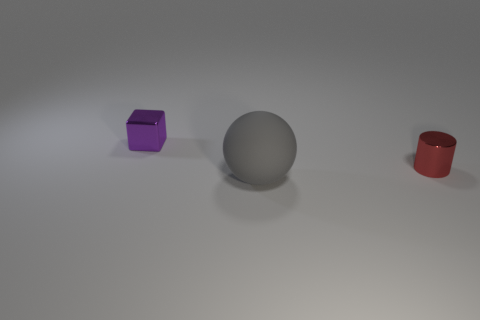The metal cylinder is what size?
Your answer should be very brief. Small. How many things are red shiny cylinders or red rubber objects?
Provide a short and direct response. 1. What color is the small cylinder that is made of the same material as the small purple object?
Keep it short and to the point. Red. Is the shape of the object that is to the right of the big gray rubber ball the same as  the gray matte object?
Your answer should be compact. No. How many things are either metallic things that are to the left of the rubber sphere or red things that are in front of the tiny purple thing?
Ensure brevity in your answer.  2. Are there any other things that are the same shape as the small purple shiny thing?
Your response must be concise. No. There is a gray thing; is its shape the same as the tiny shiny object that is in front of the tiny cube?
Provide a short and direct response. No. What is the red cylinder made of?
Ensure brevity in your answer.  Metal. What number of other things are the same material as the tiny cube?
Provide a short and direct response. 1. Is the tiny cylinder made of the same material as the big gray sphere that is in front of the tiny red metallic cylinder?
Provide a succinct answer. No. 